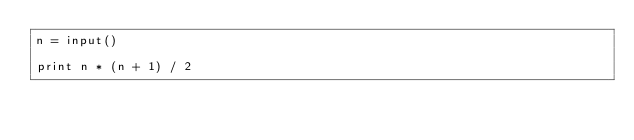<code> <loc_0><loc_0><loc_500><loc_500><_Python_>n = input()

print n * (n + 1) / 2
</code> 